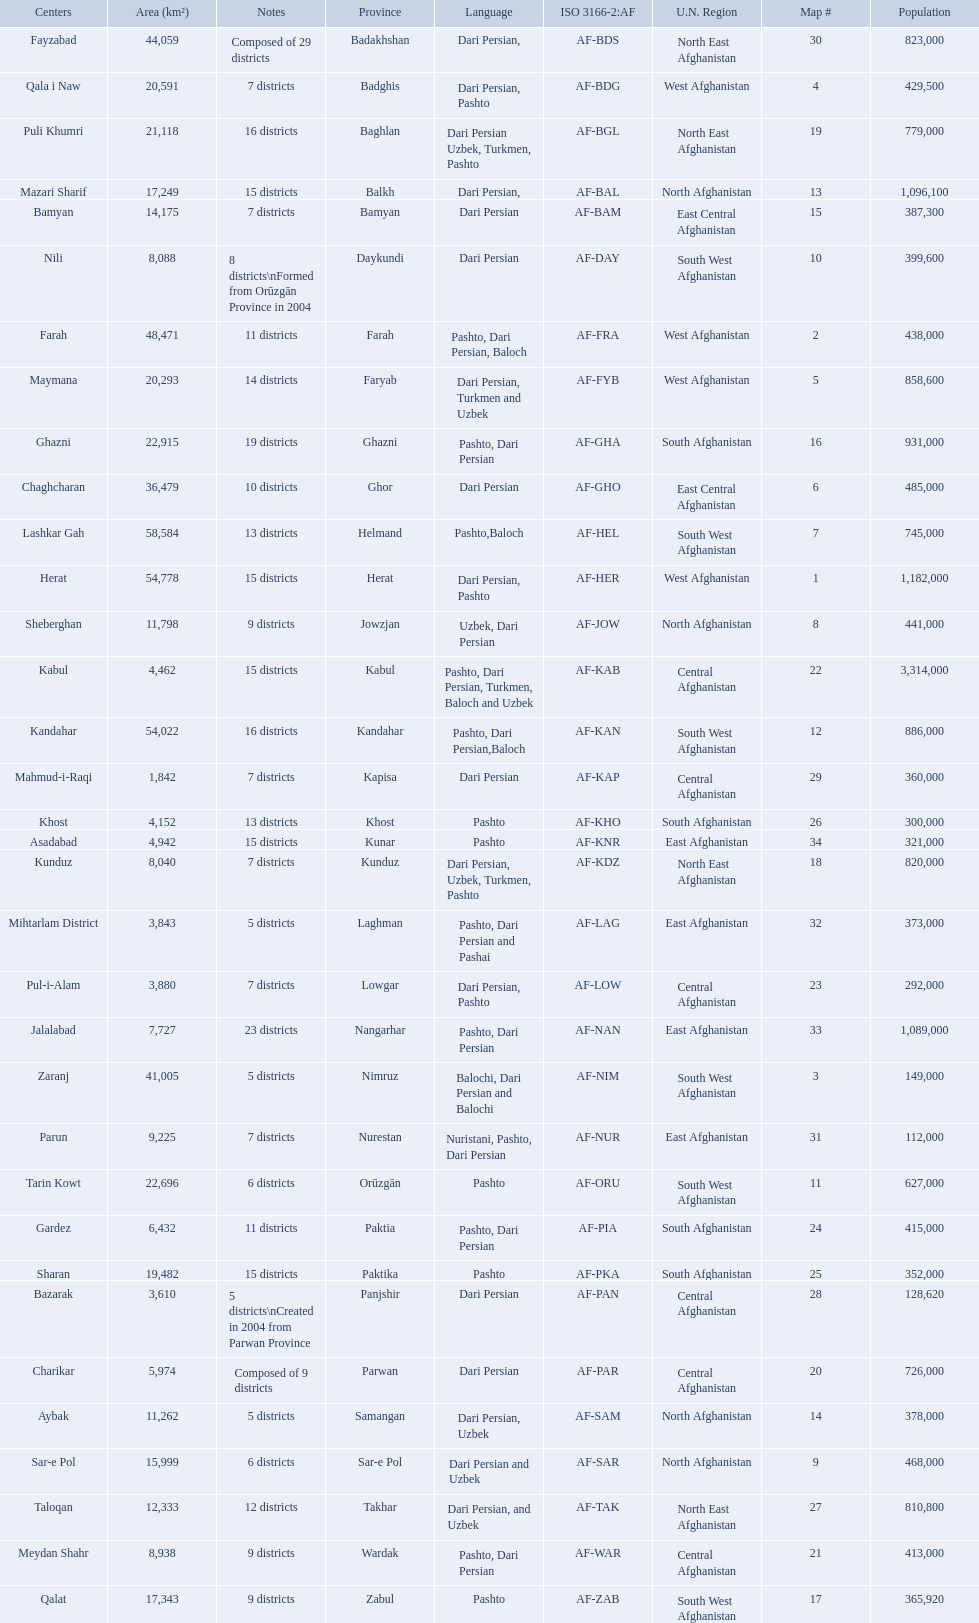Herat has a population of 1,182,000, can you list their languages Dari Persian, Pashto. 